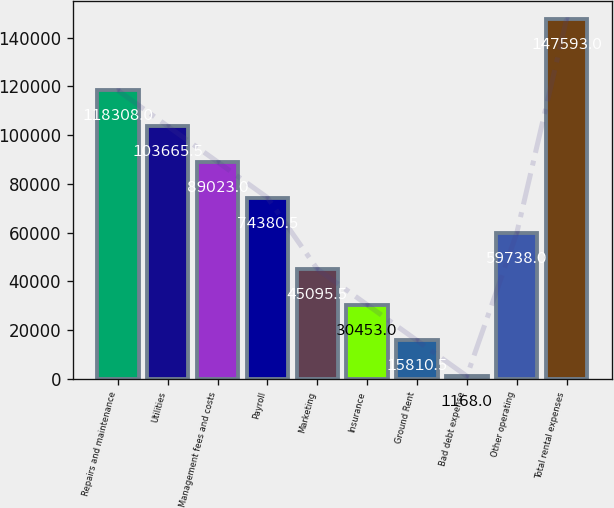<chart> <loc_0><loc_0><loc_500><loc_500><bar_chart><fcel>Repairs and maintenance<fcel>Utilities<fcel>Management fees and costs<fcel>Payroll<fcel>Marketing<fcel>Insurance<fcel>Ground Rent<fcel>Bad debt expense<fcel>Other operating<fcel>Total rental expenses<nl><fcel>118308<fcel>103666<fcel>89023<fcel>74380.5<fcel>45095.5<fcel>30453<fcel>15810.5<fcel>1168<fcel>59738<fcel>147593<nl></chart> 